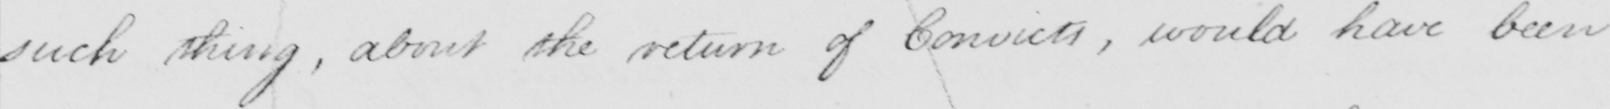Can you read and transcribe this handwriting? such thing, about the return of Convicts, would have been 